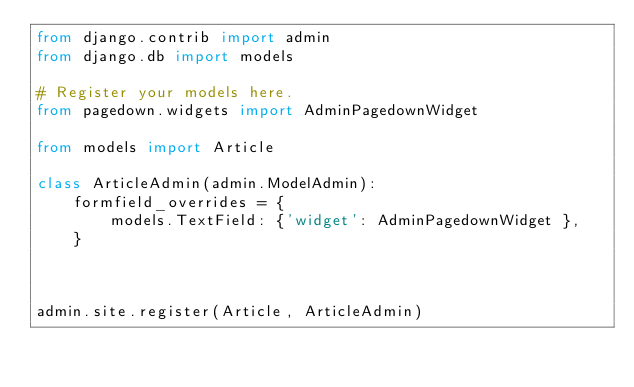Convert code to text. <code><loc_0><loc_0><loc_500><loc_500><_Python_>from django.contrib import admin
from django.db import models

# Register your models here.
from pagedown.widgets import AdminPagedownWidget

from models import Article

class ArticleAdmin(admin.ModelAdmin):
    formfield_overrides = {
        models.TextField: {'widget': AdminPagedownWidget },
    }



admin.site.register(Article, ArticleAdmin)</code> 